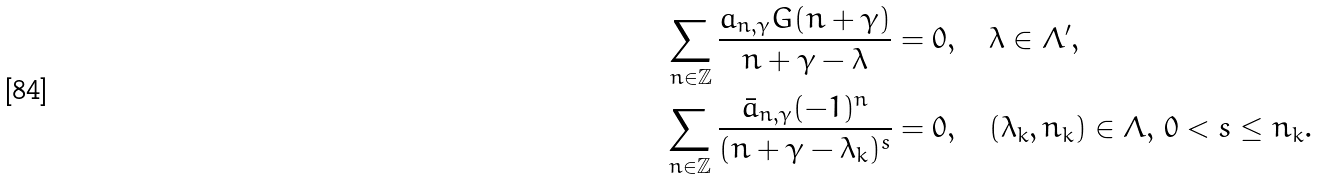Convert formula to latex. <formula><loc_0><loc_0><loc_500><loc_500>\sum _ { n \in \mathbb { Z } } \frac { a _ { n , \gamma } G ( n + \gamma ) } { n + \gamma - \lambda } & = 0 , \quad \lambda \in \Lambda ^ { \prime } , \\ \sum _ { n \in \mathbb { Z } } \frac { \bar { a } _ { n , \gamma } ( - 1 ) ^ { n } } { ( n + \gamma - \lambda _ { k } ) ^ { s } } & = 0 , \quad ( \lambda _ { k } , n _ { k } ) \in \Lambda , \, 0 < s \leq n _ { k } .</formula> 